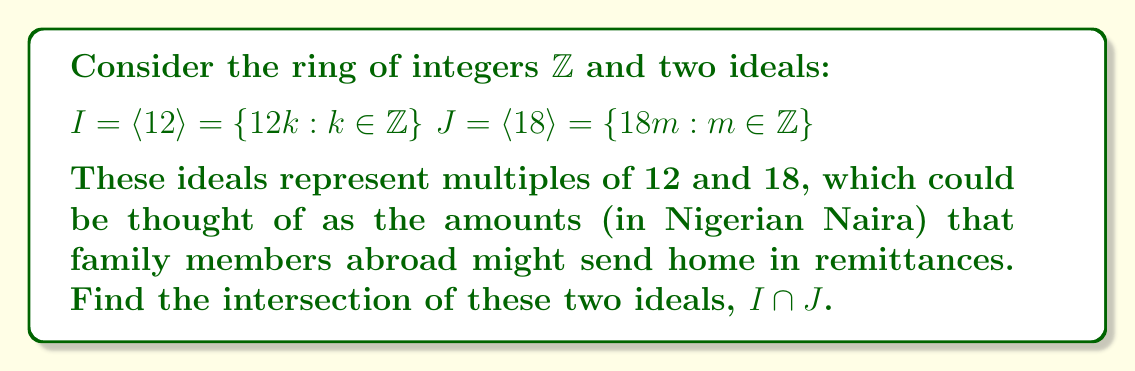Provide a solution to this math problem. To find the intersection of two ideals $I$ and $J$ in a ring, we need to determine the elements that are common to both ideals.

1) First, let's express a general element of $I$:
   $a = 12k$, where $k \in \mathbb{Z}$

2) Similarly, for $J$:
   $b = 18m$, where $m \in \mathbb{Z}$

3) For an element to be in both $I$ and $J$, it must be divisible by both 12 and 18. This means it must be divisible by the least common multiple (LCM) of 12 and 18.

4) Calculate the LCM:
   $LCM(12,18) = \frac{12 \cdot 18}{GCD(12,18)} = \frac{12 \cdot 18}{6} = 36$

5) Therefore, the intersection $I \cap J$ consists of all multiples of 36:
   $I \cap J = \langle 36 \rangle = \{36n : n \in \mathbb{Z}\}$

6) We can verify this:
   - Every multiple of 36 is a multiple of both 12 and 18.
   - Any number that is a multiple of both 12 and 18 must be a multiple of 36.

Thus, the intersection of the two ideals is the principal ideal generated by 36.
Answer: $I \cap J = \langle 36 \rangle$ 